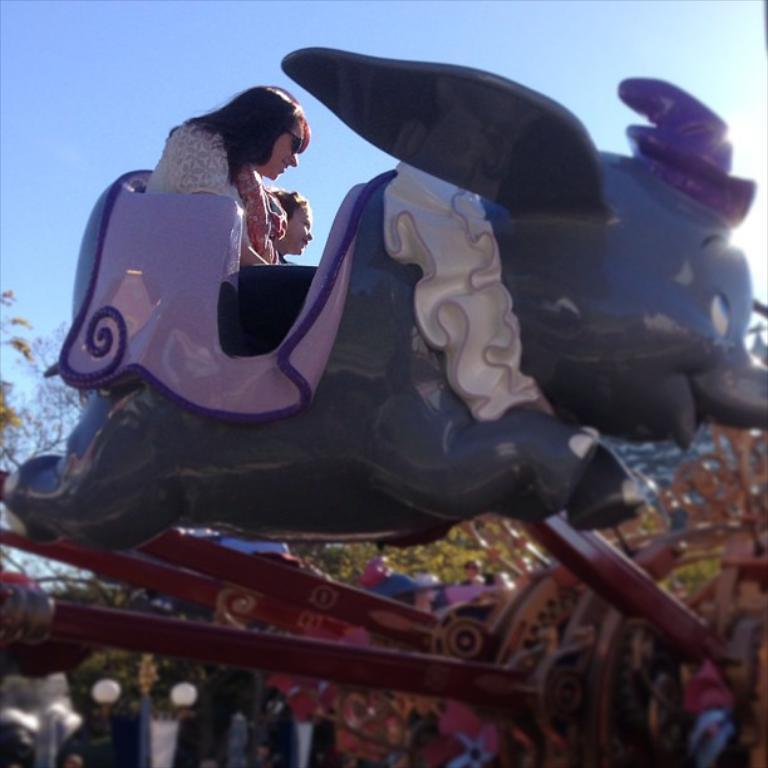What is the woman doing in the image? The woman is sitting on the seat of an object. Who is with the woman in the image? There is another person beside the woman. What can be seen in the background of the image? There are trees and a blue sky in the background of the image. What type of observation can be made about the railway in the image? There is no railway present in the image. How many patches of grass can be seen in the image? There is no mention of grass or patches in the image. 